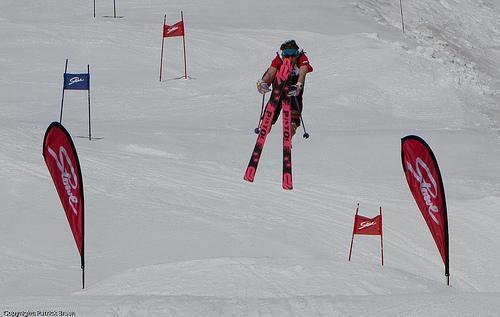How many flags are there?
Give a very brief answer. 6. How many flag posts can be seen in the ground?
Give a very brief answer. 6. How many people are pictured here?
Give a very brief answer. 1. 